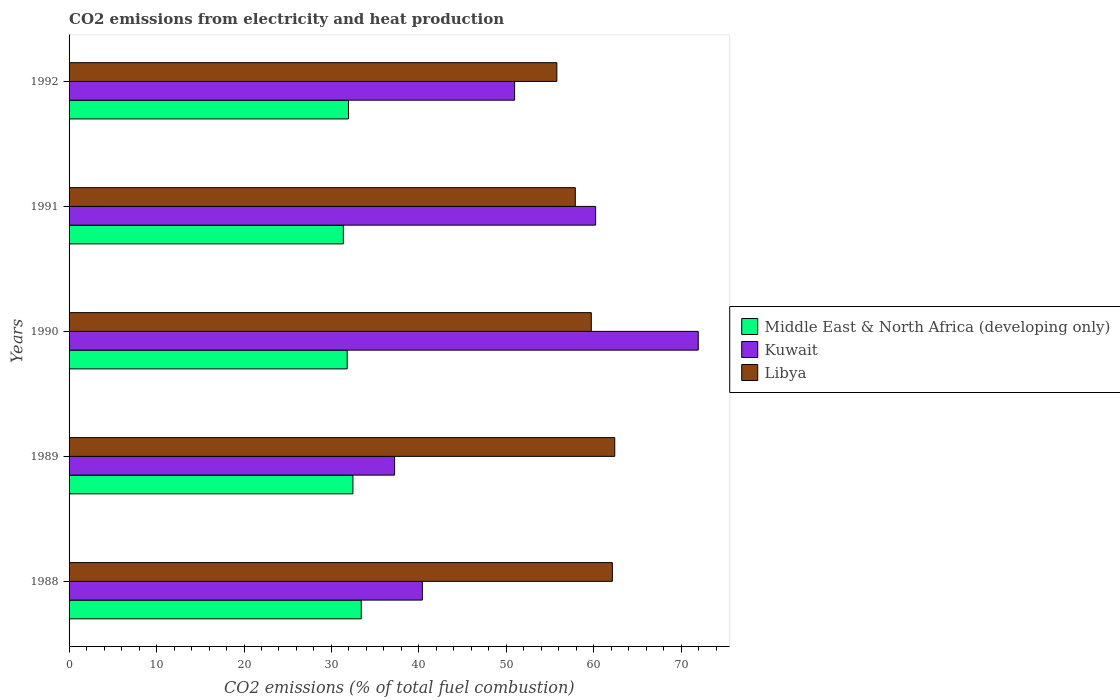How many different coloured bars are there?
Ensure brevity in your answer.  3. How many groups of bars are there?
Ensure brevity in your answer.  5. How many bars are there on the 2nd tick from the top?
Provide a short and direct response. 3. What is the label of the 1st group of bars from the top?
Give a very brief answer. 1992. What is the amount of CO2 emitted in Middle East & North Africa (developing only) in 1989?
Offer a terse response. 32.45. Across all years, what is the maximum amount of CO2 emitted in Libya?
Provide a succinct answer. 62.39. Across all years, what is the minimum amount of CO2 emitted in Middle East & North Africa (developing only)?
Provide a succinct answer. 31.36. In which year was the amount of CO2 emitted in Middle East & North Africa (developing only) maximum?
Ensure brevity in your answer.  1988. In which year was the amount of CO2 emitted in Kuwait minimum?
Give a very brief answer. 1989. What is the total amount of CO2 emitted in Libya in the graph?
Make the answer very short. 297.86. What is the difference between the amount of CO2 emitted in Middle East & North Africa (developing only) in 1990 and that in 1991?
Your response must be concise. 0.44. What is the difference between the amount of CO2 emitted in Middle East & North Africa (developing only) in 1988 and the amount of CO2 emitted in Libya in 1989?
Make the answer very short. -28.98. What is the average amount of CO2 emitted in Middle East & North Africa (developing only) per year?
Your answer should be compact. 32.19. In the year 1989, what is the difference between the amount of CO2 emitted in Middle East & North Africa (developing only) and amount of CO2 emitted in Kuwait?
Your answer should be compact. -4.76. In how many years, is the amount of CO2 emitted in Libya greater than 72 %?
Your answer should be compact. 0. What is the ratio of the amount of CO2 emitted in Libya in 1988 to that in 1990?
Provide a short and direct response. 1.04. What is the difference between the highest and the second highest amount of CO2 emitted in Middle East & North Africa (developing only)?
Provide a short and direct response. 0.95. What is the difference between the highest and the lowest amount of CO2 emitted in Libya?
Ensure brevity in your answer.  6.62. In how many years, is the amount of CO2 emitted in Kuwait greater than the average amount of CO2 emitted in Kuwait taken over all years?
Your response must be concise. 2. Is the sum of the amount of CO2 emitted in Libya in 1989 and 1990 greater than the maximum amount of CO2 emitted in Kuwait across all years?
Your answer should be compact. Yes. What does the 2nd bar from the top in 1991 represents?
Make the answer very short. Kuwait. What does the 3rd bar from the bottom in 1990 represents?
Your response must be concise. Libya. How many years are there in the graph?
Give a very brief answer. 5. Are the values on the major ticks of X-axis written in scientific E-notation?
Your answer should be very brief. No. Where does the legend appear in the graph?
Keep it short and to the point. Center right. How are the legend labels stacked?
Offer a very short reply. Vertical. What is the title of the graph?
Offer a very short reply. CO2 emissions from electricity and heat production. Does "Euro area" appear as one of the legend labels in the graph?
Make the answer very short. No. What is the label or title of the X-axis?
Ensure brevity in your answer.  CO2 emissions (% of total fuel combustion). What is the label or title of the Y-axis?
Provide a succinct answer. Years. What is the CO2 emissions (% of total fuel combustion) of Middle East & North Africa (developing only) in 1988?
Offer a terse response. 33.41. What is the CO2 emissions (% of total fuel combustion) of Kuwait in 1988?
Provide a short and direct response. 40.39. What is the CO2 emissions (% of total fuel combustion) in Libya in 1988?
Your answer should be compact. 62.12. What is the CO2 emissions (% of total fuel combustion) of Middle East & North Africa (developing only) in 1989?
Provide a short and direct response. 32.45. What is the CO2 emissions (% of total fuel combustion) of Kuwait in 1989?
Offer a terse response. 37.22. What is the CO2 emissions (% of total fuel combustion) in Libya in 1989?
Your answer should be very brief. 62.39. What is the CO2 emissions (% of total fuel combustion) in Middle East & North Africa (developing only) in 1990?
Provide a succinct answer. 31.8. What is the CO2 emissions (% of total fuel combustion) of Kuwait in 1990?
Make the answer very short. 71.94. What is the CO2 emissions (% of total fuel combustion) in Libya in 1990?
Give a very brief answer. 59.71. What is the CO2 emissions (% of total fuel combustion) in Middle East & North Africa (developing only) in 1991?
Give a very brief answer. 31.36. What is the CO2 emissions (% of total fuel combustion) in Kuwait in 1991?
Keep it short and to the point. 60.2. What is the CO2 emissions (% of total fuel combustion) of Libya in 1991?
Keep it short and to the point. 57.88. What is the CO2 emissions (% of total fuel combustion) in Middle East & North Africa (developing only) in 1992?
Offer a terse response. 31.95. What is the CO2 emissions (% of total fuel combustion) of Kuwait in 1992?
Offer a terse response. 50.94. What is the CO2 emissions (% of total fuel combustion) of Libya in 1992?
Ensure brevity in your answer.  55.77. Across all years, what is the maximum CO2 emissions (% of total fuel combustion) in Middle East & North Africa (developing only)?
Offer a terse response. 33.41. Across all years, what is the maximum CO2 emissions (% of total fuel combustion) of Kuwait?
Offer a very short reply. 71.94. Across all years, what is the maximum CO2 emissions (% of total fuel combustion) of Libya?
Give a very brief answer. 62.39. Across all years, what is the minimum CO2 emissions (% of total fuel combustion) of Middle East & North Africa (developing only)?
Your answer should be very brief. 31.36. Across all years, what is the minimum CO2 emissions (% of total fuel combustion) in Kuwait?
Offer a very short reply. 37.22. Across all years, what is the minimum CO2 emissions (% of total fuel combustion) in Libya?
Your answer should be compact. 55.77. What is the total CO2 emissions (% of total fuel combustion) of Middle East & North Africa (developing only) in the graph?
Provide a succinct answer. 160.96. What is the total CO2 emissions (% of total fuel combustion) in Kuwait in the graph?
Keep it short and to the point. 260.68. What is the total CO2 emissions (% of total fuel combustion) in Libya in the graph?
Give a very brief answer. 297.86. What is the difference between the CO2 emissions (% of total fuel combustion) of Middle East & North Africa (developing only) in 1988 and that in 1989?
Your answer should be very brief. 0.95. What is the difference between the CO2 emissions (% of total fuel combustion) in Kuwait in 1988 and that in 1989?
Provide a short and direct response. 3.17. What is the difference between the CO2 emissions (% of total fuel combustion) in Libya in 1988 and that in 1989?
Offer a very short reply. -0.27. What is the difference between the CO2 emissions (% of total fuel combustion) in Middle East & North Africa (developing only) in 1988 and that in 1990?
Ensure brevity in your answer.  1.61. What is the difference between the CO2 emissions (% of total fuel combustion) of Kuwait in 1988 and that in 1990?
Your answer should be very brief. -31.55. What is the difference between the CO2 emissions (% of total fuel combustion) in Libya in 1988 and that in 1990?
Keep it short and to the point. 2.41. What is the difference between the CO2 emissions (% of total fuel combustion) in Middle East & North Africa (developing only) in 1988 and that in 1991?
Give a very brief answer. 2.05. What is the difference between the CO2 emissions (% of total fuel combustion) of Kuwait in 1988 and that in 1991?
Keep it short and to the point. -19.81. What is the difference between the CO2 emissions (% of total fuel combustion) in Libya in 1988 and that in 1991?
Your answer should be compact. 4.24. What is the difference between the CO2 emissions (% of total fuel combustion) of Middle East & North Africa (developing only) in 1988 and that in 1992?
Provide a succinct answer. 1.46. What is the difference between the CO2 emissions (% of total fuel combustion) of Kuwait in 1988 and that in 1992?
Provide a succinct answer. -10.55. What is the difference between the CO2 emissions (% of total fuel combustion) of Libya in 1988 and that in 1992?
Offer a very short reply. 6.35. What is the difference between the CO2 emissions (% of total fuel combustion) in Middle East & North Africa (developing only) in 1989 and that in 1990?
Give a very brief answer. 0.66. What is the difference between the CO2 emissions (% of total fuel combustion) in Kuwait in 1989 and that in 1990?
Make the answer very short. -34.72. What is the difference between the CO2 emissions (% of total fuel combustion) of Libya in 1989 and that in 1990?
Offer a very short reply. 2.68. What is the difference between the CO2 emissions (% of total fuel combustion) in Middle East & North Africa (developing only) in 1989 and that in 1991?
Offer a very short reply. 1.1. What is the difference between the CO2 emissions (% of total fuel combustion) of Kuwait in 1989 and that in 1991?
Offer a terse response. -22.98. What is the difference between the CO2 emissions (% of total fuel combustion) in Libya in 1989 and that in 1991?
Make the answer very short. 4.51. What is the difference between the CO2 emissions (% of total fuel combustion) of Middle East & North Africa (developing only) in 1989 and that in 1992?
Make the answer very short. 0.51. What is the difference between the CO2 emissions (% of total fuel combustion) in Kuwait in 1989 and that in 1992?
Your answer should be compact. -13.72. What is the difference between the CO2 emissions (% of total fuel combustion) of Libya in 1989 and that in 1992?
Provide a short and direct response. 6.62. What is the difference between the CO2 emissions (% of total fuel combustion) of Middle East & North Africa (developing only) in 1990 and that in 1991?
Your answer should be compact. 0.44. What is the difference between the CO2 emissions (% of total fuel combustion) of Kuwait in 1990 and that in 1991?
Your answer should be very brief. 11.73. What is the difference between the CO2 emissions (% of total fuel combustion) of Libya in 1990 and that in 1991?
Provide a short and direct response. 1.83. What is the difference between the CO2 emissions (% of total fuel combustion) in Middle East & North Africa (developing only) in 1990 and that in 1992?
Your answer should be very brief. -0.15. What is the difference between the CO2 emissions (% of total fuel combustion) in Kuwait in 1990 and that in 1992?
Your answer should be compact. 21. What is the difference between the CO2 emissions (% of total fuel combustion) of Libya in 1990 and that in 1992?
Your response must be concise. 3.94. What is the difference between the CO2 emissions (% of total fuel combustion) of Middle East & North Africa (developing only) in 1991 and that in 1992?
Make the answer very short. -0.59. What is the difference between the CO2 emissions (% of total fuel combustion) of Kuwait in 1991 and that in 1992?
Offer a very short reply. 9.26. What is the difference between the CO2 emissions (% of total fuel combustion) of Libya in 1991 and that in 1992?
Provide a succinct answer. 2.11. What is the difference between the CO2 emissions (% of total fuel combustion) of Middle East & North Africa (developing only) in 1988 and the CO2 emissions (% of total fuel combustion) of Kuwait in 1989?
Your answer should be compact. -3.81. What is the difference between the CO2 emissions (% of total fuel combustion) of Middle East & North Africa (developing only) in 1988 and the CO2 emissions (% of total fuel combustion) of Libya in 1989?
Provide a short and direct response. -28.98. What is the difference between the CO2 emissions (% of total fuel combustion) in Kuwait in 1988 and the CO2 emissions (% of total fuel combustion) in Libya in 1989?
Offer a terse response. -22. What is the difference between the CO2 emissions (% of total fuel combustion) of Middle East & North Africa (developing only) in 1988 and the CO2 emissions (% of total fuel combustion) of Kuwait in 1990?
Your answer should be very brief. -38.53. What is the difference between the CO2 emissions (% of total fuel combustion) of Middle East & North Africa (developing only) in 1988 and the CO2 emissions (% of total fuel combustion) of Libya in 1990?
Offer a terse response. -26.3. What is the difference between the CO2 emissions (% of total fuel combustion) in Kuwait in 1988 and the CO2 emissions (% of total fuel combustion) in Libya in 1990?
Offer a very short reply. -19.32. What is the difference between the CO2 emissions (% of total fuel combustion) in Middle East & North Africa (developing only) in 1988 and the CO2 emissions (% of total fuel combustion) in Kuwait in 1991?
Offer a very short reply. -26.79. What is the difference between the CO2 emissions (% of total fuel combustion) of Middle East & North Africa (developing only) in 1988 and the CO2 emissions (% of total fuel combustion) of Libya in 1991?
Provide a succinct answer. -24.47. What is the difference between the CO2 emissions (% of total fuel combustion) in Kuwait in 1988 and the CO2 emissions (% of total fuel combustion) in Libya in 1991?
Your answer should be very brief. -17.49. What is the difference between the CO2 emissions (% of total fuel combustion) in Middle East & North Africa (developing only) in 1988 and the CO2 emissions (% of total fuel combustion) in Kuwait in 1992?
Provide a succinct answer. -17.53. What is the difference between the CO2 emissions (% of total fuel combustion) in Middle East & North Africa (developing only) in 1988 and the CO2 emissions (% of total fuel combustion) in Libya in 1992?
Make the answer very short. -22.36. What is the difference between the CO2 emissions (% of total fuel combustion) in Kuwait in 1988 and the CO2 emissions (% of total fuel combustion) in Libya in 1992?
Your answer should be compact. -15.38. What is the difference between the CO2 emissions (% of total fuel combustion) of Middle East & North Africa (developing only) in 1989 and the CO2 emissions (% of total fuel combustion) of Kuwait in 1990?
Make the answer very short. -39.48. What is the difference between the CO2 emissions (% of total fuel combustion) of Middle East & North Africa (developing only) in 1989 and the CO2 emissions (% of total fuel combustion) of Libya in 1990?
Make the answer very short. -27.25. What is the difference between the CO2 emissions (% of total fuel combustion) of Kuwait in 1989 and the CO2 emissions (% of total fuel combustion) of Libya in 1990?
Offer a terse response. -22.49. What is the difference between the CO2 emissions (% of total fuel combustion) of Middle East & North Africa (developing only) in 1989 and the CO2 emissions (% of total fuel combustion) of Kuwait in 1991?
Offer a very short reply. -27.75. What is the difference between the CO2 emissions (% of total fuel combustion) in Middle East & North Africa (developing only) in 1989 and the CO2 emissions (% of total fuel combustion) in Libya in 1991?
Ensure brevity in your answer.  -25.42. What is the difference between the CO2 emissions (% of total fuel combustion) of Kuwait in 1989 and the CO2 emissions (% of total fuel combustion) of Libya in 1991?
Your answer should be very brief. -20.66. What is the difference between the CO2 emissions (% of total fuel combustion) of Middle East & North Africa (developing only) in 1989 and the CO2 emissions (% of total fuel combustion) of Kuwait in 1992?
Provide a short and direct response. -18.48. What is the difference between the CO2 emissions (% of total fuel combustion) of Middle East & North Africa (developing only) in 1989 and the CO2 emissions (% of total fuel combustion) of Libya in 1992?
Provide a short and direct response. -23.32. What is the difference between the CO2 emissions (% of total fuel combustion) of Kuwait in 1989 and the CO2 emissions (% of total fuel combustion) of Libya in 1992?
Give a very brief answer. -18.55. What is the difference between the CO2 emissions (% of total fuel combustion) of Middle East & North Africa (developing only) in 1990 and the CO2 emissions (% of total fuel combustion) of Kuwait in 1991?
Your response must be concise. -28.41. What is the difference between the CO2 emissions (% of total fuel combustion) in Middle East & North Africa (developing only) in 1990 and the CO2 emissions (% of total fuel combustion) in Libya in 1991?
Provide a succinct answer. -26.08. What is the difference between the CO2 emissions (% of total fuel combustion) of Kuwait in 1990 and the CO2 emissions (% of total fuel combustion) of Libya in 1991?
Offer a terse response. 14.06. What is the difference between the CO2 emissions (% of total fuel combustion) in Middle East & North Africa (developing only) in 1990 and the CO2 emissions (% of total fuel combustion) in Kuwait in 1992?
Offer a terse response. -19.14. What is the difference between the CO2 emissions (% of total fuel combustion) in Middle East & North Africa (developing only) in 1990 and the CO2 emissions (% of total fuel combustion) in Libya in 1992?
Keep it short and to the point. -23.97. What is the difference between the CO2 emissions (% of total fuel combustion) of Kuwait in 1990 and the CO2 emissions (% of total fuel combustion) of Libya in 1992?
Give a very brief answer. 16.17. What is the difference between the CO2 emissions (% of total fuel combustion) in Middle East & North Africa (developing only) in 1991 and the CO2 emissions (% of total fuel combustion) in Kuwait in 1992?
Make the answer very short. -19.58. What is the difference between the CO2 emissions (% of total fuel combustion) in Middle East & North Africa (developing only) in 1991 and the CO2 emissions (% of total fuel combustion) in Libya in 1992?
Keep it short and to the point. -24.41. What is the difference between the CO2 emissions (% of total fuel combustion) in Kuwait in 1991 and the CO2 emissions (% of total fuel combustion) in Libya in 1992?
Your response must be concise. 4.43. What is the average CO2 emissions (% of total fuel combustion) in Middle East & North Africa (developing only) per year?
Your answer should be compact. 32.19. What is the average CO2 emissions (% of total fuel combustion) in Kuwait per year?
Ensure brevity in your answer.  52.14. What is the average CO2 emissions (% of total fuel combustion) of Libya per year?
Provide a short and direct response. 59.57. In the year 1988, what is the difference between the CO2 emissions (% of total fuel combustion) of Middle East & North Africa (developing only) and CO2 emissions (% of total fuel combustion) of Kuwait?
Give a very brief answer. -6.98. In the year 1988, what is the difference between the CO2 emissions (% of total fuel combustion) of Middle East & North Africa (developing only) and CO2 emissions (% of total fuel combustion) of Libya?
Provide a short and direct response. -28.71. In the year 1988, what is the difference between the CO2 emissions (% of total fuel combustion) in Kuwait and CO2 emissions (% of total fuel combustion) in Libya?
Offer a terse response. -21.73. In the year 1989, what is the difference between the CO2 emissions (% of total fuel combustion) in Middle East & North Africa (developing only) and CO2 emissions (% of total fuel combustion) in Kuwait?
Provide a short and direct response. -4.76. In the year 1989, what is the difference between the CO2 emissions (% of total fuel combustion) of Middle East & North Africa (developing only) and CO2 emissions (% of total fuel combustion) of Libya?
Make the answer very short. -29.93. In the year 1989, what is the difference between the CO2 emissions (% of total fuel combustion) in Kuwait and CO2 emissions (% of total fuel combustion) in Libya?
Give a very brief answer. -25.17. In the year 1990, what is the difference between the CO2 emissions (% of total fuel combustion) of Middle East & North Africa (developing only) and CO2 emissions (% of total fuel combustion) of Kuwait?
Provide a short and direct response. -40.14. In the year 1990, what is the difference between the CO2 emissions (% of total fuel combustion) of Middle East & North Africa (developing only) and CO2 emissions (% of total fuel combustion) of Libya?
Offer a very short reply. -27.91. In the year 1990, what is the difference between the CO2 emissions (% of total fuel combustion) of Kuwait and CO2 emissions (% of total fuel combustion) of Libya?
Offer a very short reply. 12.23. In the year 1991, what is the difference between the CO2 emissions (% of total fuel combustion) of Middle East & North Africa (developing only) and CO2 emissions (% of total fuel combustion) of Kuwait?
Your response must be concise. -28.84. In the year 1991, what is the difference between the CO2 emissions (% of total fuel combustion) of Middle East & North Africa (developing only) and CO2 emissions (% of total fuel combustion) of Libya?
Ensure brevity in your answer.  -26.52. In the year 1991, what is the difference between the CO2 emissions (% of total fuel combustion) in Kuwait and CO2 emissions (% of total fuel combustion) in Libya?
Your answer should be compact. 2.32. In the year 1992, what is the difference between the CO2 emissions (% of total fuel combustion) of Middle East & North Africa (developing only) and CO2 emissions (% of total fuel combustion) of Kuwait?
Provide a succinct answer. -18.99. In the year 1992, what is the difference between the CO2 emissions (% of total fuel combustion) of Middle East & North Africa (developing only) and CO2 emissions (% of total fuel combustion) of Libya?
Your response must be concise. -23.82. In the year 1992, what is the difference between the CO2 emissions (% of total fuel combustion) of Kuwait and CO2 emissions (% of total fuel combustion) of Libya?
Ensure brevity in your answer.  -4.83. What is the ratio of the CO2 emissions (% of total fuel combustion) in Middle East & North Africa (developing only) in 1988 to that in 1989?
Offer a terse response. 1.03. What is the ratio of the CO2 emissions (% of total fuel combustion) of Kuwait in 1988 to that in 1989?
Keep it short and to the point. 1.09. What is the ratio of the CO2 emissions (% of total fuel combustion) of Middle East & North Africa (developing only) in 1988 to that in 1990?
Make the answer very short. 1.05. What is the ratio of the CO2 emissions (% of total fuel combustion) in Kuwait in 1988 to that in 1990?
Offer a very short reply. 0.56. What is the ratio of the CO2 emissions (% of total fuel combustion) of Libya in 1988 to that in 1990?
Offer a very short reply. 1.04. What is the ratio of the CO2 emissions (% of total fuel combustion) in Middle East & North Africa (developing only) in 1988 to that in 1991?
Your response must be concise. 1.07. What is the ratio of the CO2 emissions (% of total fuel combustion) in Kuwait in 1988 to that in 1991?
Your response must be concise. 0.67. What is the ratio of the CO2 emissions (% of total fuel combustion) of Libya in 1988 to that in 1991?
Provide a succinct answer. 1.07. What is the ratio of the CO2 emissions (% of total fuel combustion) of Middle East & North Africa (developing only) in 1988 to that in 1992?
Your answer should be compact. 1.05. What is the ratio of the CO2 emissions (% of total fuel combustion) of Kuwait in 1988 to that in 1992?
Keep it short and to the point. 0.79. What is the ratio of the CO2 emissions (% of total fuel combustion) of Libya in 1988 to that in 1992?
Ensure brevity in your answer.  1.11. What is the ratio of the CO2 emissions (% of total fuel combustion) in Middle East & North Africa (developing only) in 1989 to that in 1990?
Your answer should be compact. 1.02. What is the ratio of the CO2 emissions (% of total fuel combustion) of Kuwait in 1989 to that in 1990?
Make the answer very short. 0.52. What is the ratio of the CO2 emissions (% of total fuel combustion) in Libya in 1989 to that in 1990?
Your answer should be compact. 1.04. What is the ratio of the CO2 emissions (% of total fuel combustion) of Middle East & North Africa (developing only) in 1989 to that in 1991?
Provide a short and direct response. 1.03. What is the ratio of the CO2 emissions (% of total fuel combustion) of Kuwait in 1989 to that in 1991?
Provide a short and direct response. 0.62. What is the ratio of the CO2 emissions (% of total fuel combustion) of Libya in 1989 to that in 1991?
Your response must be concise. 1.08. What is the ratio of the CO2 emissions (% of total fuel combustion) in Middle East & North Africa (developing only) in 1989 to that in 1992?
Give a very brief answer. 1.02. What is the ratio of the CO2 emissions (% of total fuel combustion) of Kuwait in 1989 to that in 1992?
Your response must be concise. 0.73. What is the ratio of the CO2 emissions (% of total fuel combustion) of Libya in 1989 to that in 1992?
Your response must be concise. 1.12. What is the ratio of the CO2 emissions (% of total fuel combustion) in Middle East & North Africa (developing only) in 1990 to that in 1991?
Offer a terse response. 1.01. What is the ratio of the CO2 emissions (% of total fuel combustion) in Kuwait in 1990 to that in 1991?
Your response must be concise. 1.19. What is the ratio of the CO2 emissions (% of total fuel combustion) in Libya in 1990 to that in 1991?
Keep it short and to the point. 1.03. What is the ratio of the CO2 emissions (% of total fuel combustion) of Middle East & North Africa (developing only) in 1990 to that in 1992?
Provide a short and direct response. 1. What is the ratio of the CO2 emissions (% of total fuel combustion) in Kuwait in 1990 to that in 1992?
Make the answer very short. 1.41. What is the ratio of the CO2 emissions (% of total fuel combustion) of Libya in 1990 to that in 1992?
Give a very brief answer. 1.07. What is the ratio of the CO2 emissions (% of total fuel combustion) in Middle East & North Africa (developing only) in 1991 to that in 1992?
Make the answer very short. 0.98. What is the ratio of the CO2 emissions (% of total fuel combustion) of Kuwait in 1991 to that in 1992?
Your answer should be compact. 1.18. What is the ratio of the CO2 emissions (% of total fuel combustion) in Libya in 1991 to that in 1992?
Your response must be concise. 1.04. What is the difference between the highest and the second highest CO2 emissions (% of total fuel combustion) in Middle East & North Africa (developing only)?
Your response must be concise. 0.95. What is the difference between the highest and the second highest CO2 emissions (% of total fuel combustion) of Kuwait?
Make the answer very short. 11.73. What is the difference between the highest and the second highest CO2 emissions (% of total fuel combustion) of Libya?
Your answer should be compact. 0.27. What is the difference between the highest and the lowest CO2 emissions (% of total fuel combustion) of Middle East & North Africa (developing only)?
Ensure brevity in your answer.  2.05. What is the difference between the highest and the lowest CO2 emissions (% of total fuel combustion) in Kuwait?
Your answer should be compact. 34.72. What is the difference between the highest and the lowest CO2 emissions (% of total fuel combustion) of Libya?
Offer a terse response. 6.62. 